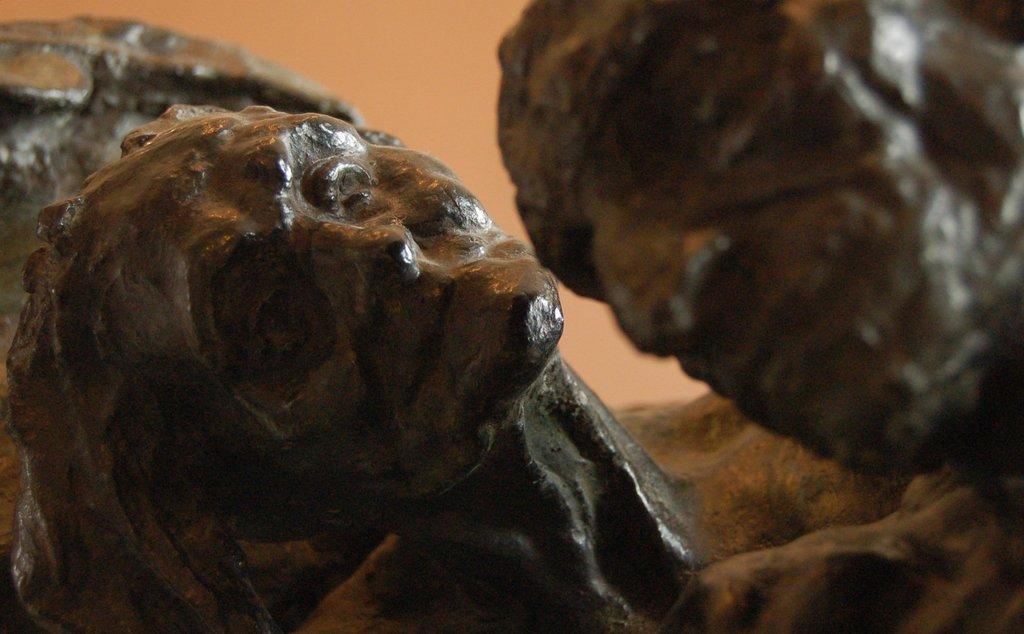How would you summarize this image in a sentence or two? In this image I can see sculptures. I can see a man and a woman sculptures along with some other sculptures.  